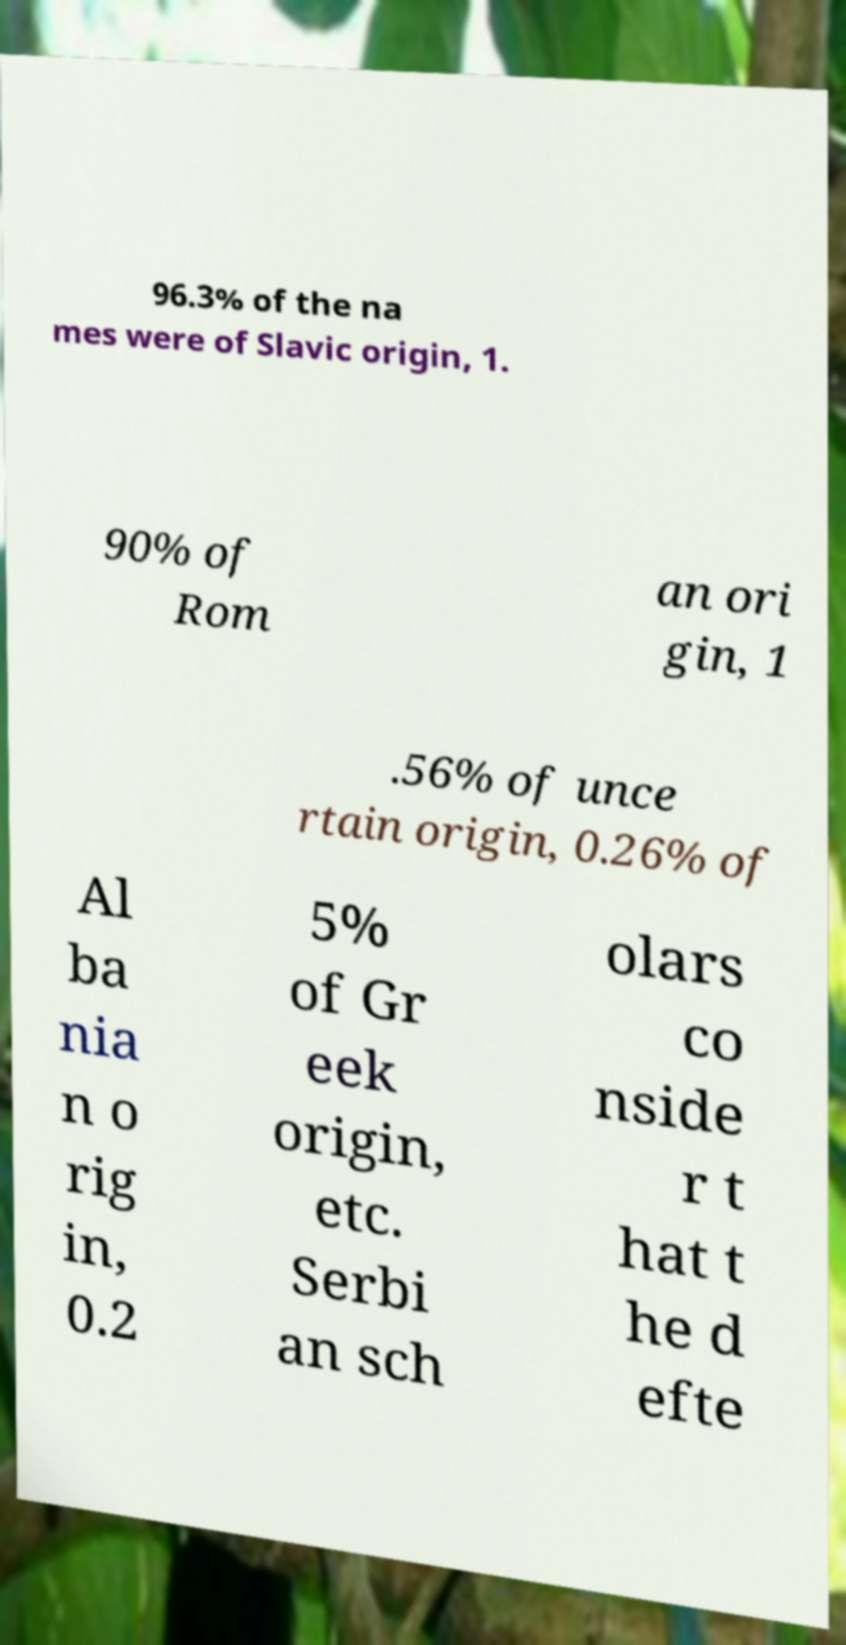Can you read and provide the text displayed in the image?This photo seems to have some interesting text. Can you extract and type it out for me? 96.3% of the na mes were of Slavic origin, 1. 90% of Rom an ori gin, 1 .56% of unce rtain origin, 0.26% of Al ba nia n o rig in, 0.2 5% of Gr eek origin, etc. Serbi an sch olars co nside r t hat t he d efte 